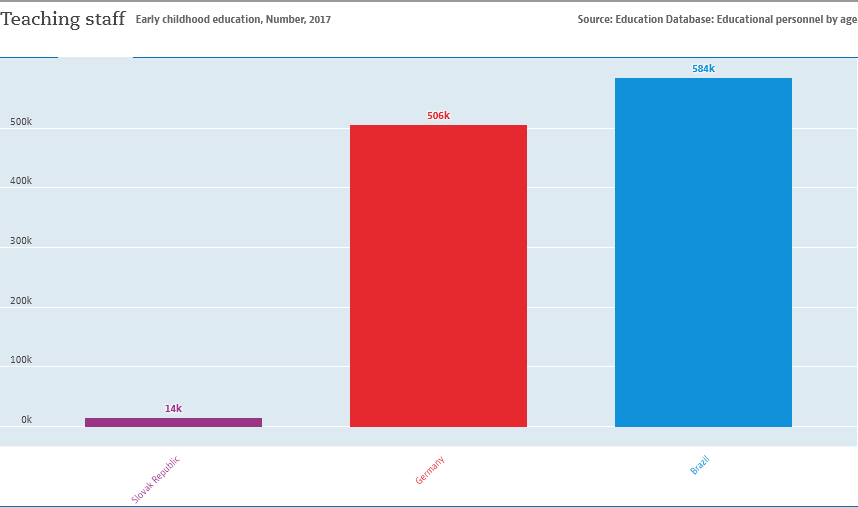List a handful of essential elements in this visual. In the data, the median value of all bars is less than 600,000. As of 2021, the number of teaching staff in Germany is approximately 506. 